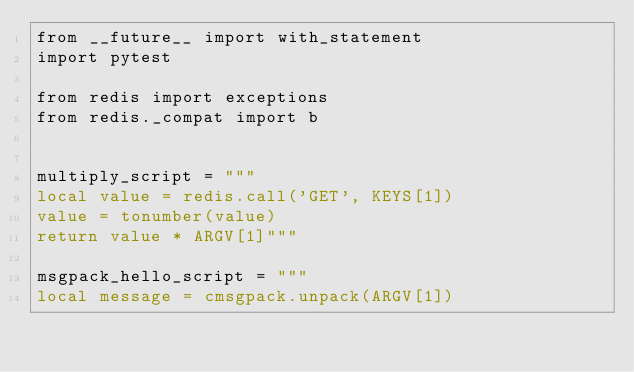Convert code to text. <code><loc_0><loc_0><loc_500><loc_500><_Python_>from __future__ import with_statement
import pytest

from redis import exceptions
from redis._compat import b


multiply_script = """
local value = redis.call('GET', KEYS[1])
value = tonumber(value)
return value * ARGV[1]"""

msgpack_hello_script = """
local message = cmsgpack.unpack(ARGV[1])</code> 